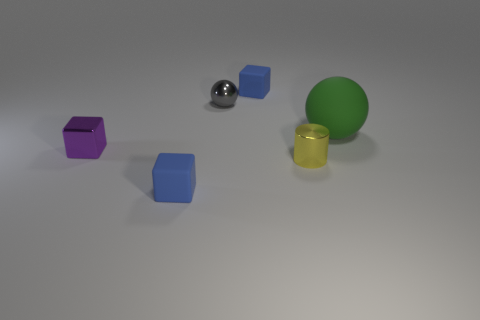Is the color of the rubber block behind the purple metal cube the same as the small matte block that is in front of the tiny purple block?
Make the answer very short. Yes. There is a small blue cube that is behind the tiny matte cube to the left of the shiny thing behind the purple cube; what is it made of?
Your answer should be very brief. Rubber. Do the gray thing and the big green sphere have the same material?
Give a very brief answer. No. What number of small gray metal objects are in front of the purple metal object behind the rubber object that is in front of the tiny purple shiny cube?
Keep it short and to the point. 0. What color is the tiny rubber object that is behind the green ball?
Your answer should be very brief. Blue. What shape is the small rubber thing that is behind the matte cube that is in front of the small gray ball?
Make the answer very short. Cube. How many spheres are either tiny red metallic things or yellow metal things?
Offer a very short reply. 0. What material is the block that is both behind the small cylinder and right of the tiny metal block?
Provide a short and direct response. Rubber. How many big things are on the right side of the large green rubber sphere?
Make the answer very short. 0. Does the small blue cube in front of the small yellow metal cylinder have the same material as the small blue thing behind the yellow object?
Your answer should be very brief. Yes. 